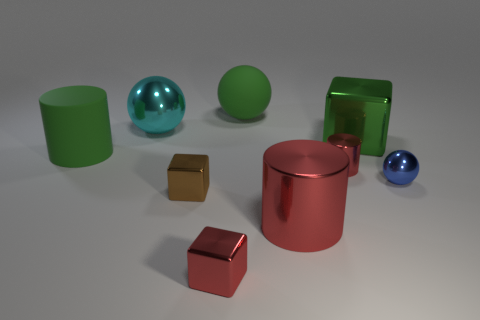Subtract all tiny cubes. How many cubes are left? 1 Subtract all blue blocks. How many red cylinders are left? 2 Subtract all red cubes. How many cubes are left? 2 Subtract 1 blocks. How many blocks are left? 2 Subtract all cylinders. How many objects are left? 6 Subtract all gray cubes. Subtract all green spheres. How many cubes are left? 3 Subtract 0 yellow balls. How many objects are left? 9 Subtract all red metal objects. Subtract all big shiny spheres. How many objects are left? 5 Add 6 tiny brown metallic things. How many tiny brown metallic things are left? 7 Add 8 big blocks. How many big blocks exist? 9 